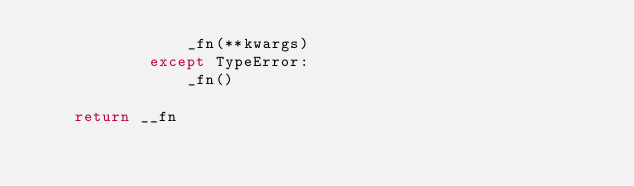Convert code to text. <code><loc_0><loc_0><loc_500><loc_500><_Python_>                _fn(**kwargs)
            except TypeError:
                _fn()

    return __fn
</code> 